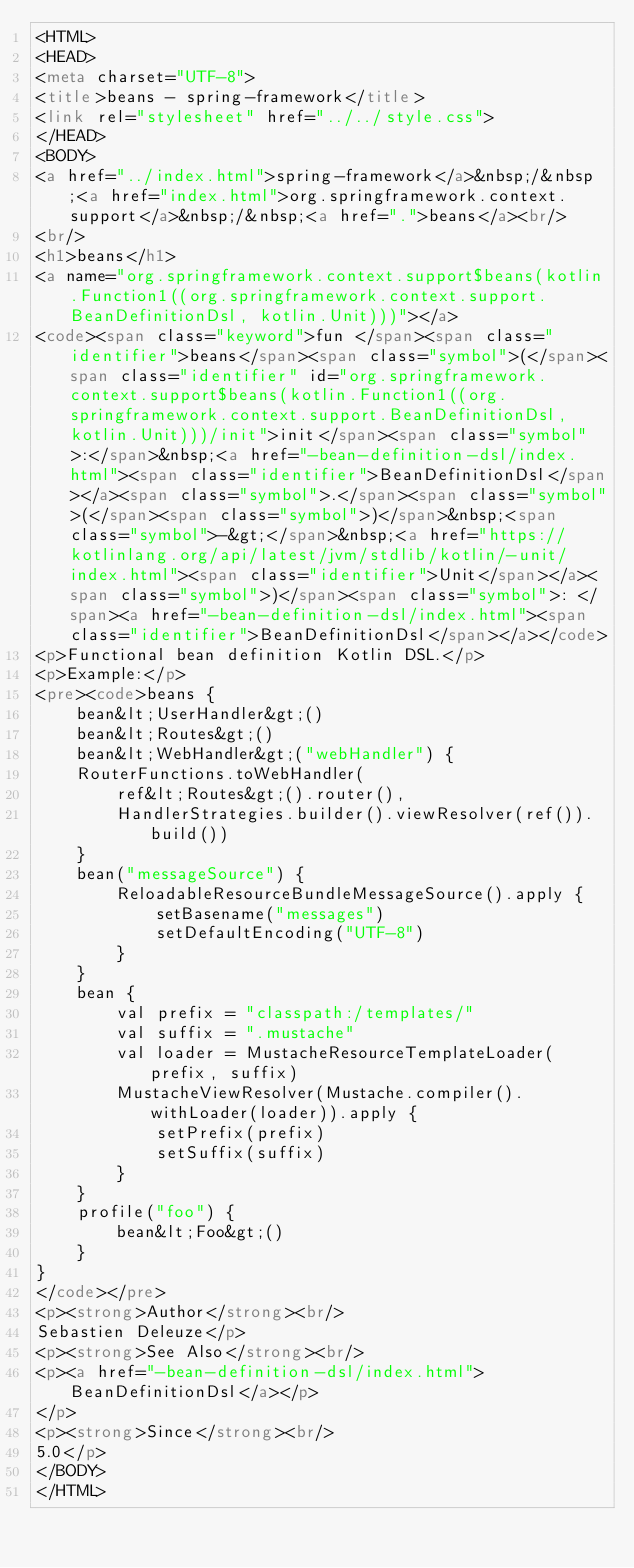<code> <loc_0><loc_0><loc_500><loc_500><_HTML_><HTML>
<HEAD>
<meta charset="UTF-8">
<title>beans - spring-framework</title>
<link rel="stylesheet" href="../../style.css">
</HEAD>
<BODY>
<a href="../index.html">spring-framework</a>&nbsp;/&nbsp;<a href="index.html">org.springframework.context.support</a>&nbsp;/&nbsp;<a href=".">beans</a><br/>
<br/>
<h1>beans</h1>
<a name="org.springframework.context.support$beans(kotlin.Function1((org.springframework.context.support.BeanDefinitionDsl, kotlin.Unit)))"></a>
<code><span class="keyword">fun </span><span class="identifier">beans</span><span class="symbol">(</span><span class="identifier" id="org.springframework.context.support$beans(kotlin.Function1((org.springframework.context.support.BeanDefinitionDsl, kotlin.Unit)))/init">init</span><span class="symbol">:</span>&nbsp;<a href="-bean-definition-dsl/index.html"><span class="identifier">BeanDefinitionDsl</span></a><span class="symbol">.</span><span class="symbol">(</span><span class="symbol">)</span>&nbsp;<span class="symbol">-&gt;</span>&nbsp;<a href="https://kotlinlang.org/api/latest/jvm/stdlib/kotlin/-unit/index.html"><span class="identifier">Unit</span></a><span class="symbol">)</span><span class="symbol">: </span><a href="-bean-definition-dsl/index.html"><span class="identifier">BeanDefinitionDsl</span></a></code>
<p>Functional bean definition Kotlin DSL.</p>
<p>Example:</p>
<pre><code>beans {
	bean&lt;UserHandler&gt;()
	bean&lt;Routes&gt;()
	bean&lt;WebHandler&gt;("webHandler") {
	RouterFunctions.toWebHandler(
		ref&lt;Routes&gt;().router(),
		HandlerStrategies.builder().viewResolver(ref()).build())
	}
	bean("messageSource") {
		ReloadableResourceBundleMessageSource().apply {
			setBasename("messages")
			setDefaultEncoding("UTF-8")
		}
	}
	bean {
		val prefix = "classpath:/templates/"
		val suffix = ".mustache"
		val loader = MustacheResourceTemplateLoader(prefix, suffix)
		MustacheViewResolver(Mustache.compiler().withLoader(loader)).apply {
			setPrefix(prefix)
			setSuffix(suffix)
		}
	}
	profile("foo") {
		bean&lt;Foo&gt;()
	}
}
</code></pre>
<p><strong>Author</strong><br/>
Sebastien Deleuze</p>
<p><strong>See Also</strong><br/>
<p><a href="-bean-definition-dsl/index.html">BeanDefinitionDsl</a></p>
</p>
<p><strong>Since</strong><br/>
5.0</p>
</BODY>
</HTML>
</code> 